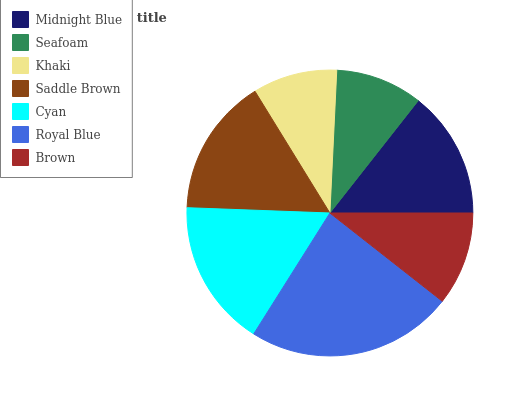Is Khaki the minimum?
Answer yes or no. Yes. Is Royal Blue the maximum?
Answer yes or no. Yes. Is Seafoam the minimum?
Answer yes or no. No. Is Seafoam the maximum?
Answer yes or no. No. Is Midnight Blue greater than Seafoam?
Answer yes or no. Yes. Is Seafoam less than Midnight Blue?
Answer yes or no. Yes. Is Seafoam greater than Midnight Blue?
Answer yes or no. No. Is Midnight Blue less than Seafoam?
Answer yes or no. No. Is Midnight Blue the high median?
Answer yes or no. Yes. Is Midnight Blue the low median?
Answer yes or no. Yes. Is Saddle Brown the high median?
Answer yes or no. No. Is Royal Blue the low median?
Answer yes or no. No. 